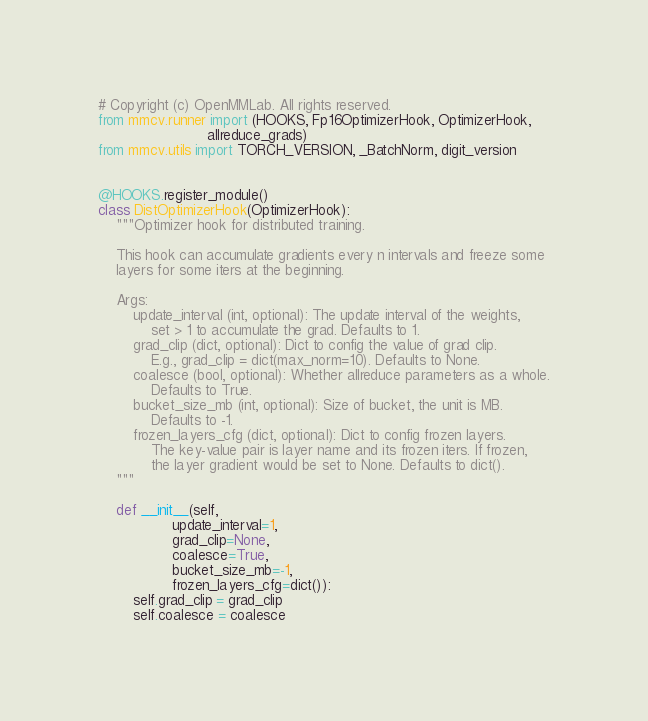<code> <loc_0><loc_0><loc_500><loc_500><_Python_># Copyright (c) OpenMMLab. All rights reserved.
from mmcv.runner import (HOOKS, Fp16OptimizerHook, OptimizerHook,
                         allreduce_grads)
from mmcv.utils import TORCH_VERSION, _BatchNorm, digit_version


@HOOKS.register_module()
class DistOptimizerHook(OptimizerHook):
    """Optimizer hook for distributed training.

    This hook can accumulate gradients every n intervals and freeze some
    layers for some iters at the beginning.

    Args:
        update_interval (int, optional): The update interval of the weights,
            set > 1 to accumulate the grad. Defaults to 1.
        grad_clip (dict, optional): Dict to config the value of grad clip.
            E.g., grad_clip = dict(max_norm=10). Defaults to None.
        coalesce (bool, optional): Whether allreduce parameters as a whole.
            Defaults to True.
        bucket_size_mb (int, optional): Size of bucket, the unit is MB.
            Defaults to -1.
        frozen_layers_cfg (dict, optional): Dict to config frozen layers.
            The key-value pair is layer name and its frozen iters. If frozen,
            the layer gradient would be set to None. Defaults to dict().
    """

    def __init__(self,
                 update_interval=1,
                 grad_clip=None,
                 coalesce=True,
                 bucket_size_mb=-1,
                 frozen_layers_cfg=dict()):
        self.grad_clip = grad_clip
        self.coalesce = coalesce</code> 